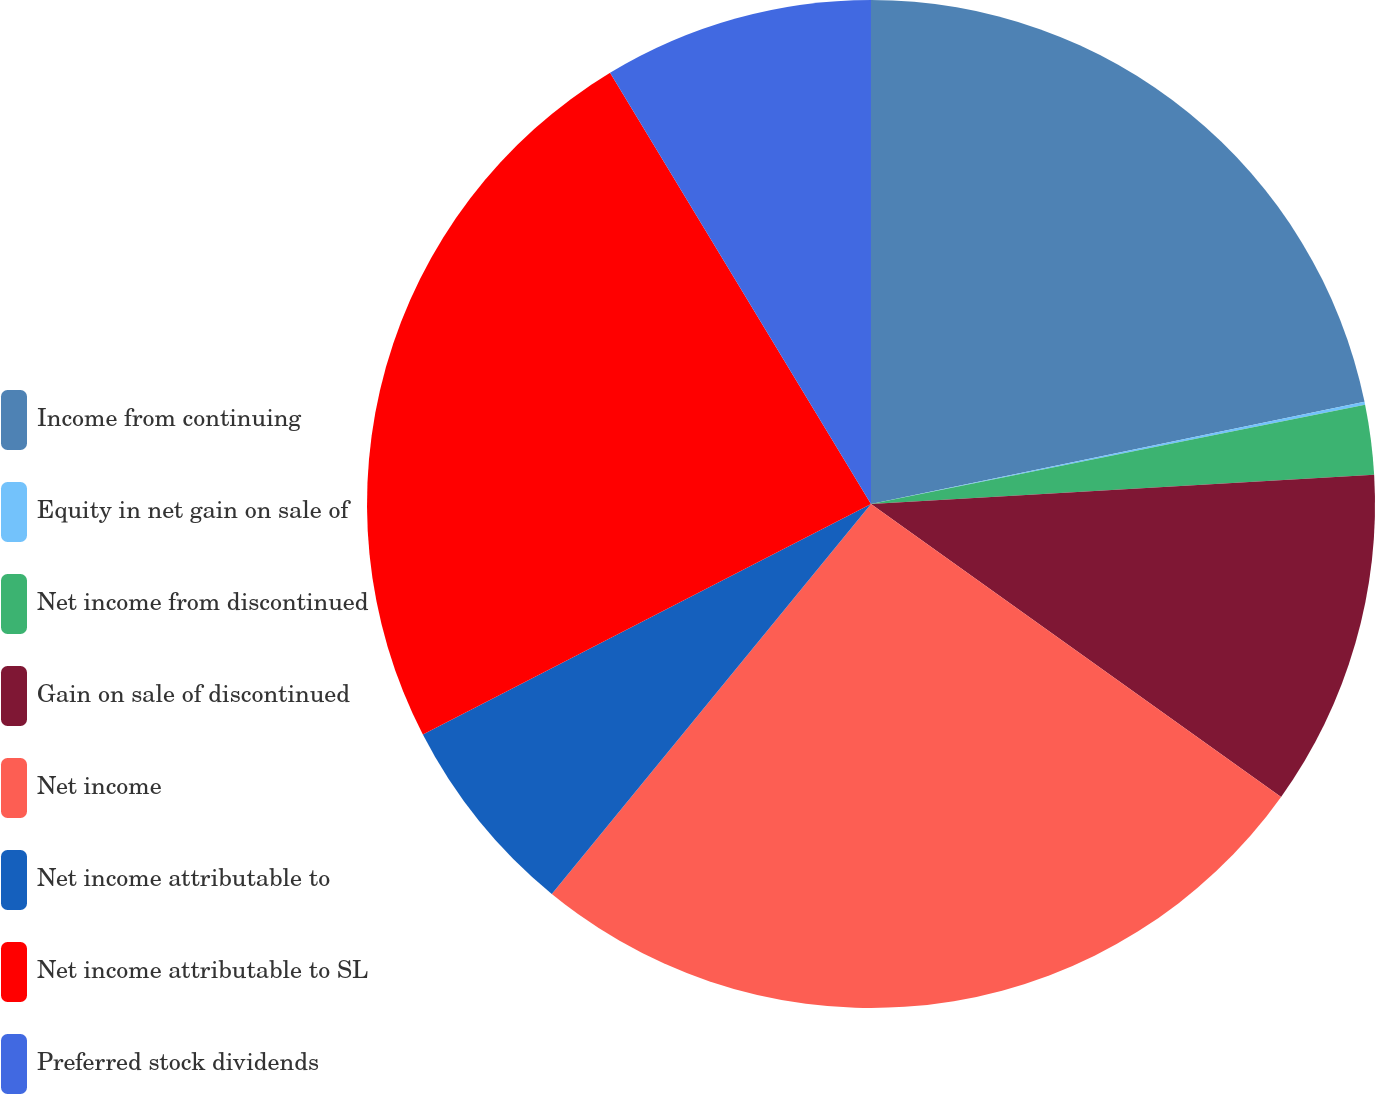Convert chart. <chart><loc_0><loc_0><loc_500><loc_500><pie_chart><fcel>Income from continuing<fcel>Equity in net gain on sale of<fcel>Net income from discontinued<fcel>Gain on sale of discontinued<fcel>Net income<fcel>Net income attributable to<fcel>Net income attributable to SL<fcel>Preferred stock dividends<nl><fcel>21.75%<fcel>0.09%<fcel>2.23%<fcel>10.8%<fcel>26.04%<fcel>6.52%<fcel>23.9%<fcel>8.66%<nl></chart> 